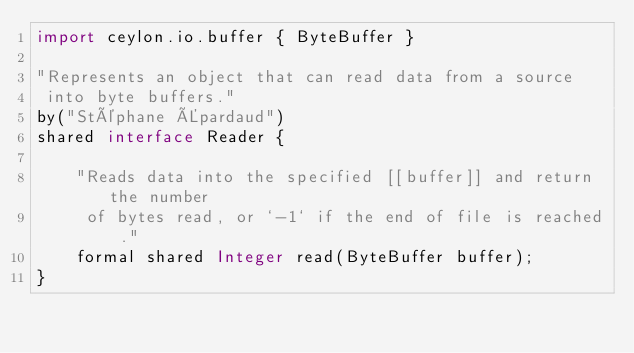<code> <loc_0><loc_0><loc_500><loc_500><_Ceylon_>import ceylon.io.buffer { ByteBuffer }

"Represents an object that can read data from a source
 into byte buffers."
by("Stéphane Épardaud")
shared interface Reader {
    
    "Reads data into the specified [[buffer]] and return the number
     of bytes read, or `-1` if the end of file is reached."
    formal shared Integer read(ByteBuffer buffer);
}</code> 